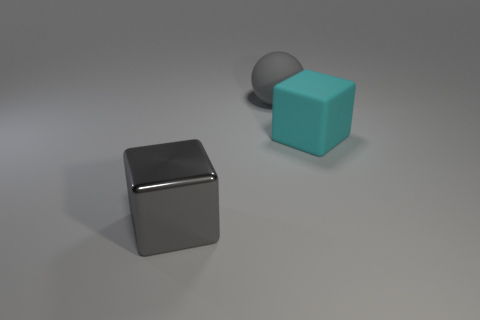Add 1 rubber blocks. How many objects exist? 4 Subtract all spheres. How many objects are left? 2 Add 2 small cyan matte things. How many small cyan matte things exist? 2 Subtract 0 blue blocks. How many objects are left? 3 Subtract all metallic blocks. Subtract all cyan cubes. How many objects are left? 1 Add 2 big things. How many big things are left? 5 